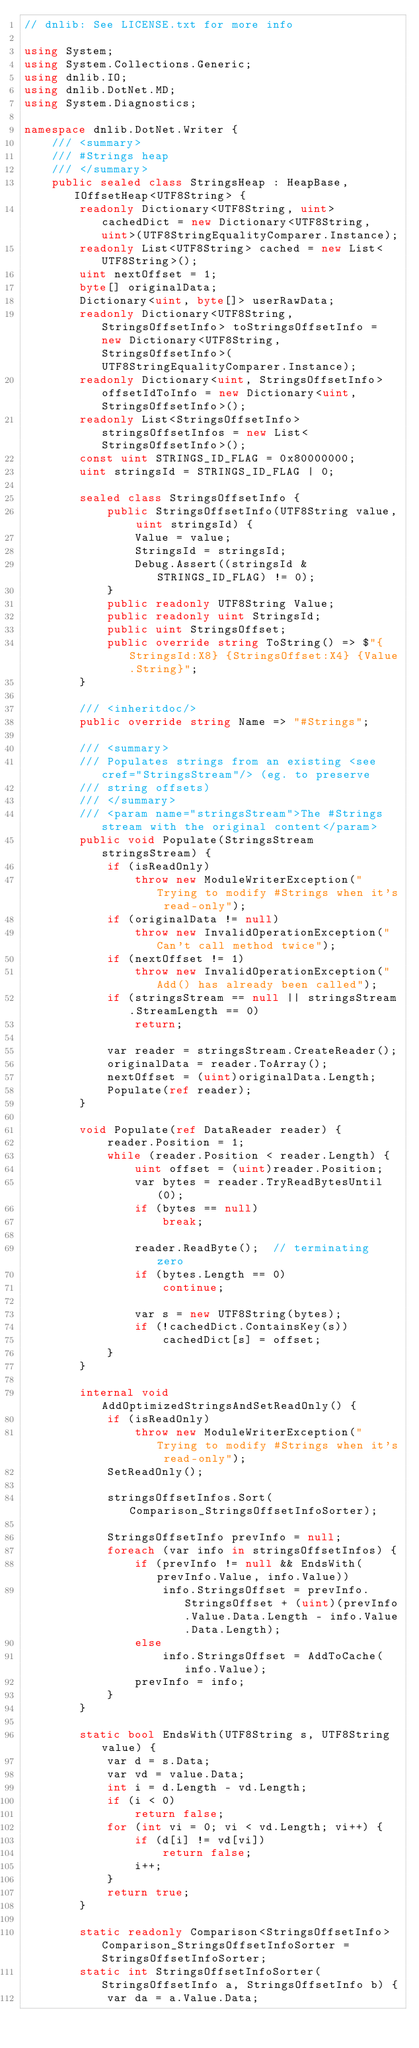<code> <loc_0><loc_0><loc_500><loc_500><_C#_>// dnlib: See LICENSE.txt for more info

using System;
using System.Collections.Generic;
using dnlib.IO;
using dnlib.DotNet.MD;
using System.Diagnostics;

namespace dnlib.DotNet.Writer {
	/// <summary>
	/// #Strings heap
	/// </summary>
	public sealed class StringsHeap : HeapBase, IOffsetHeap<UTF8String> {
		readonly Dictionary<UTF8String, uint> cachedDict = new Dictionary<UTF8String, uint>(UTF8StringEqualityComparer.Instance);
		readonly List<UTF8String> cached = new List<UTF8String>();
		uint nextOffset = 1;
		byte[] originalData;
		Dictionary<uint, byte[]> userRawData;
		readonly Dictionary<UTF8String, StringsOffsetInfo> toStringsOffsetInfo = new Dictionary<UTF8String, StringsOffsetInfo>(UTF8StringEqualityComparer.Instance);
		readonly Dictionary<uint, StringsOffsetInfo> offsetIdToInfo = new Dictionary<uint, StringsOffsetInfo>();
		readonly List<StringsOffsetInfo> stringsOffsetInfos = new List<StringsOffsetInfo>();
		const uint STRINGS_ID_FLAG = 0x80000000;
		uint stringsId = STRINGS_ID_FLAG | 0;

		sealed class StringsOffsetInfo {
			public StringsOffsetInfo(UTF8String value, uint stringsId) {
				Value = value;
				StringsId = stringsId;
				Debug.Assert((stringsId & STRINGS_ID_FLAG) != 0);
			}
			public readonly UTF8String Value;
			public readonly uint StringsId;
			public uint StringsOffset;
			public override string ToString() => $"{StringsId:X8} {StringsOffset:X4} {Value.String}";
		}

		/// <inheritdoc/>
		public override string Name => "#Strings";

		/// <summary>
		/// Populates strings from an existing <see cref="StringsStream"/> (eg. to preserve
		/// string offsets)
		/// </summary>
		/// <param name="stringsStream">The #Strings stream with the original content</param>
		public void Populate(StringsStream stringsStream) {
			if (isReadOnly)
				throw new ModuleWriterException("Trying to modify #Strings when it's read-only");
			if (originalData != null)
				throw new InvalidOperationException("Can't call method twice");
			if (nextOffset != 1)
				throw new InvalidOperationException("Add() has already been called");
			if (stringsStream == null || stringsStream.StreamLength == 0)
				return;

			var reader = stringsStream.CreateReader();
			originalData = reader.ToArray();
			nextOffset = (uint)originalData.Length;
			Populate(ref reader);
		}

		void Populate(ref DataReader reader) {
			reader.Position = 1;
			while (reader.Position < reader.Length) {
				uint offset = (uint)reader.Position;
				var bytes = reader.TryReadBytesUntil(0);
				if (bytes == null)
					break;

				reader.ReadByte();	// terminating zero
				if (bytes.Length == 0)
					continue;

				var s = new UTF8String(bytes);
				if (!cachedDict.ContainsKey(s))
					cachedDict[s] = offset;
			}
		}

		internal void AddOptimizedStringsAndSetReadOnly() {
			if (isReadOnly)
				throw new ModuleWriterException("Trying to modify #Strings when it's read-only");
			SetReadOnly();

			stringsOffsetInfos.Sort(Comparison_StringsOffsetInfoSorter);

			StringsOffsetInfo prevInfo = null;
			foreach (var info in stringsOffsetInfos) {
				if (prevInfo != null && EndsWith(prevInfo.Value, info.Value))
					info.StringsOffset = prevInfo.StringsOffset + (uint)(prevInfo.Value.Data.Length - info.Value.Data.Length);
				else
					info.StringsOffset = AddToCache(info.Value);
				prevInfo = info;
			}
		}

		static bool EndsWith(UTF8String s, UTF8String value) {
			var d = s.Data;
			var vd = value.Data;
			int i = d.Length - vd.Length;
			if (i < 0)
				return false;
			for (int vi = 0; vi < vd.Length; vi++) {
				if (d[i] != vd[vi])
					return false;
				i++;
			}
			return true;
		}

		static readonly Comparison<StringsOffsetInfo> Comparison_StringsOffsetInfoSorter = StringsOffsetInfoSorter;
		static int StringsOffsetInfoSorter(StringsOffsetInfo a, StringsOffsetInfo b) {
			var da = a.Value.Data;</code> 